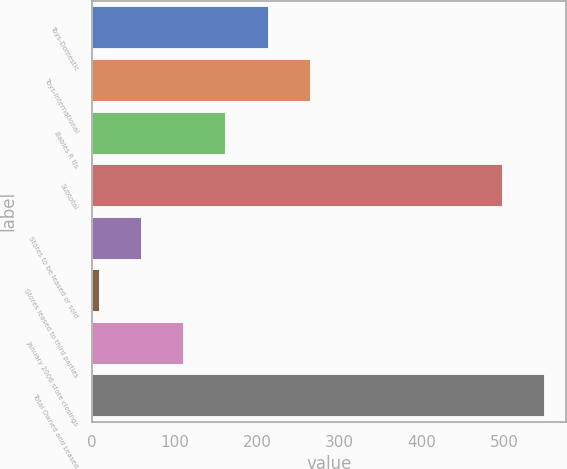Convert chart to OTSL. <chart><loc_0><loc_0><loc_500><loc_500><bar_chart><fcel>Toys-Domestic<fcel>Toys-International<fcel>Babies R Us<fcel>Subtotal<fcel>Stores to be leased or sold<fcel>Stores leased to third parties<fcel>January 2006 store closings<fcel>Total Owned and Leased<nl><fcel>213.2<fcel>264.5<fcel>161.9<fcel>497<fcel>59.3<fcel>8<fcel>110.6<fcel>548.3<nl></chart> 